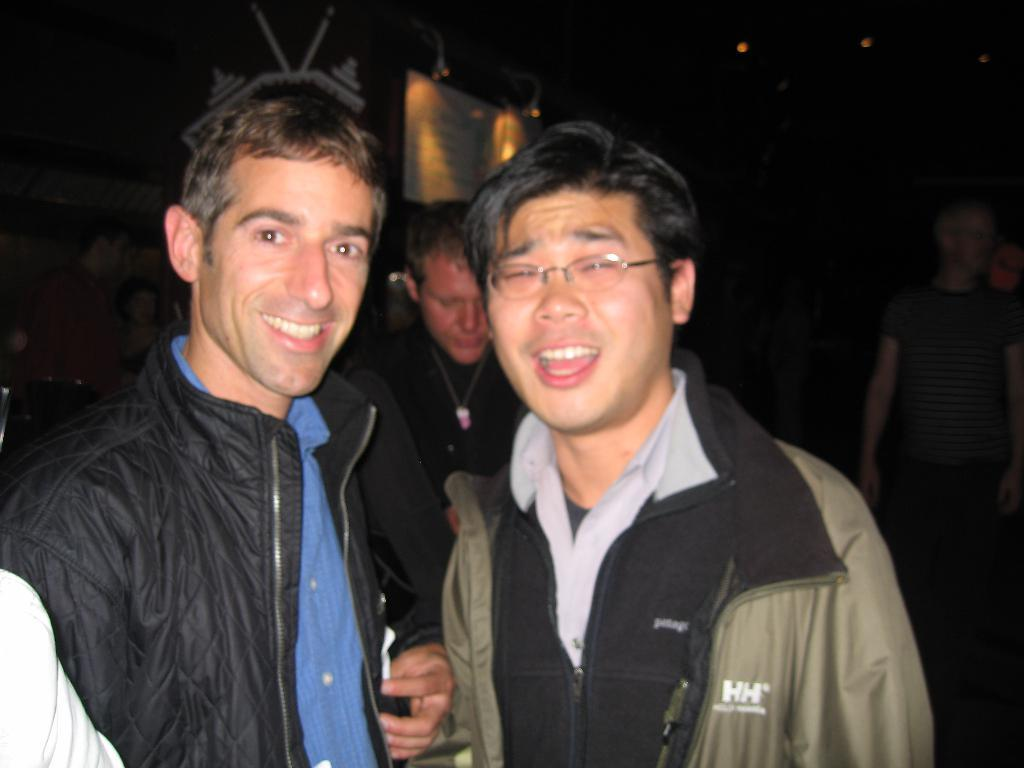How many people are in the image? There are two boys in the image. What are the boys wearing? The boys are wearing jackets. What expression do the boys have in the image? The boys are smiling in the image. What are the boys doing in the image? The boys are posing for the camera. What is the color of the background in the image? The background in the image is black. Can you see the boys kicking a soccer ball in the image? No, there is no soccer ball or any indication of the boys kicking in the image. 